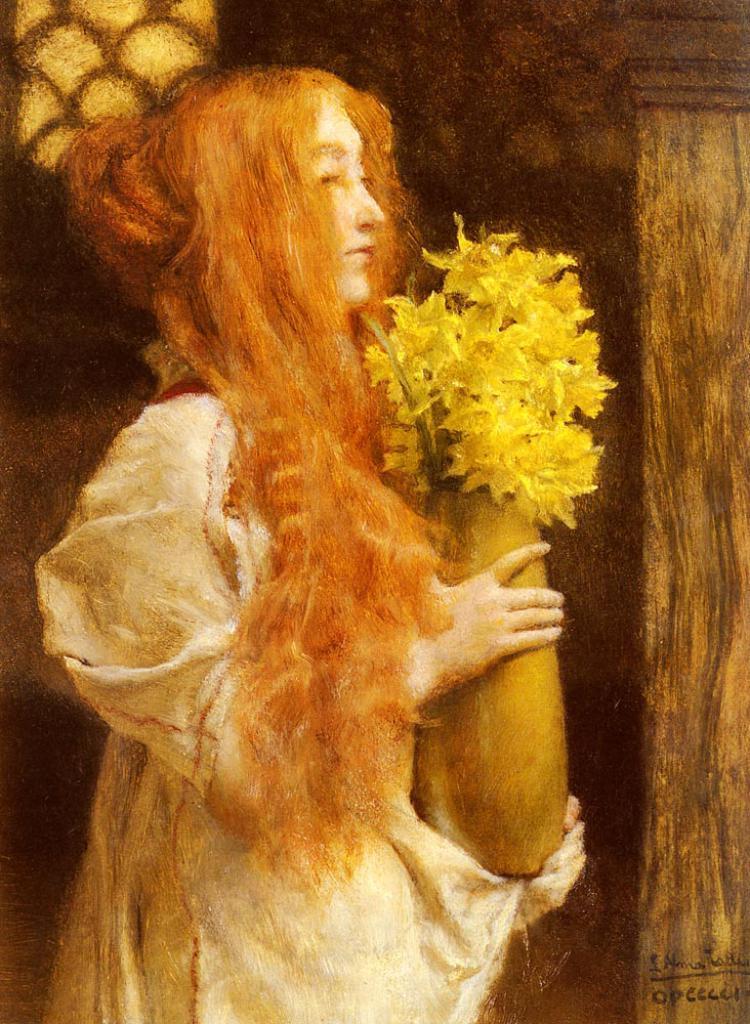Describe this image in one or two sentences. There is a painting, in which, there is a woman in white color dress, holding a flower vase, which is having yellow color flowers, near wooden pillar. In the background, there are other objects. 